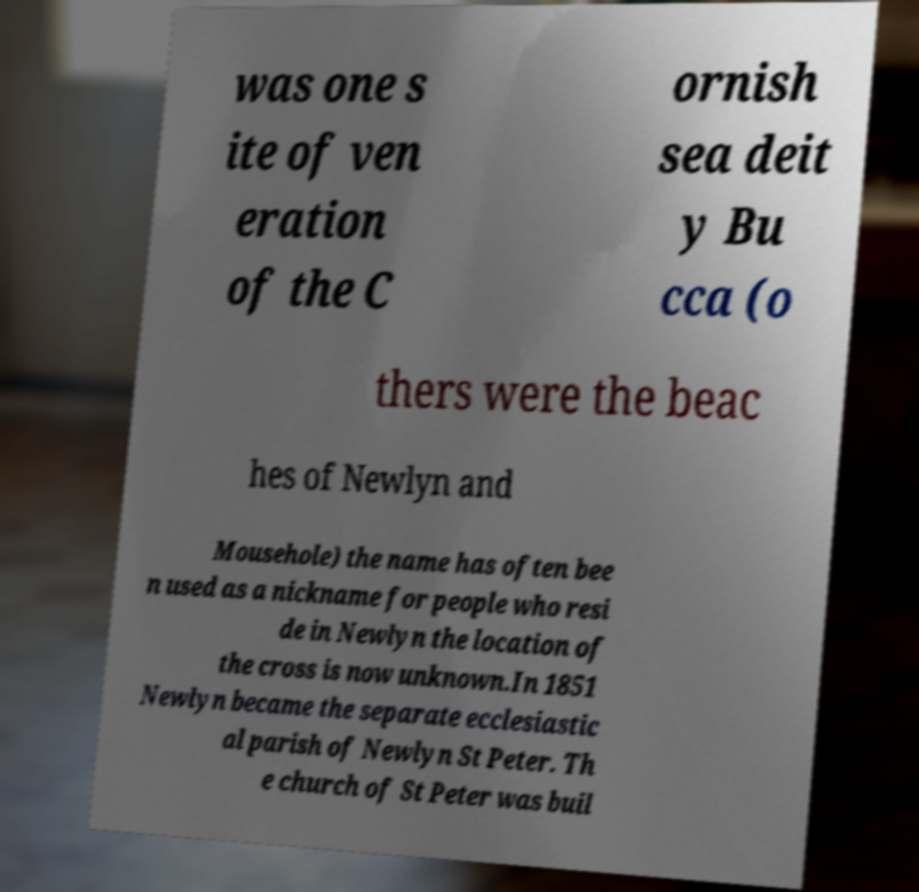For documentation purposes, I need the text within this image transcribed. Could you provide that? was one s ite of ven eration of the C ornish sea deit y Bu cca (o thers were the beac hes of Newlyn and Mousehole) the name has often bee n used as a nickname for people who resi de in Newlyn the location of the cross is now unknown.In 1851 Newlyn became the separate ecclesiastic al parish of Newlyn St Peter. Th e church of St Peter was buil 